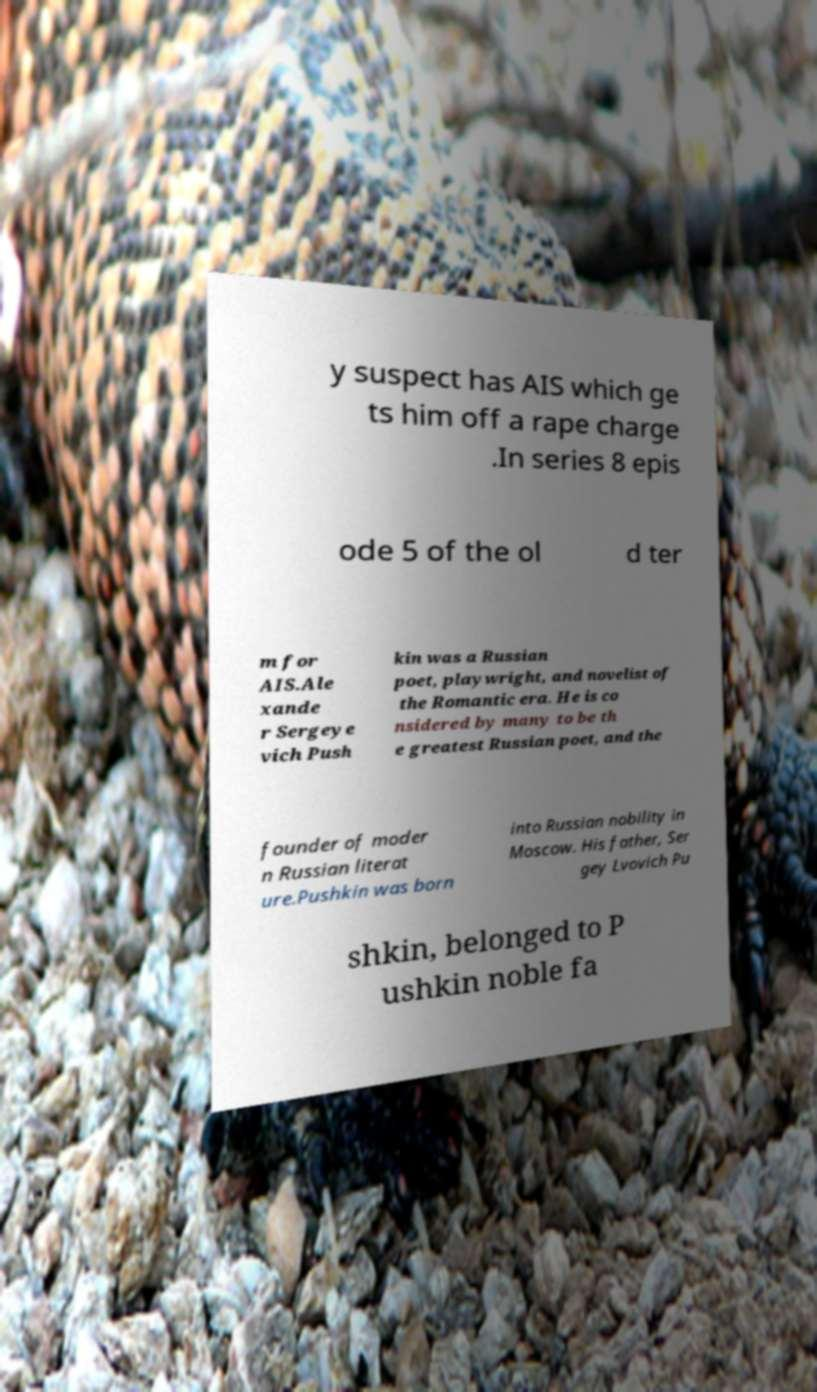Can you accurately transcribe the text from the provided image for me? y suspect has AIS which ge ts him off a rape charge .In series 8 epis ode 5 of the ol d ter m for AIS.Ale xande r Sergeye vich Push kin was a Russian poet, playwright, and novelist of the Romantic era. He is co nsidered by many to be th e greatest Russian poet, and the founder of moder n Russian literat ure.Pushkin was born into Russian nobility in Moscow. His father, Ser gey Lvovich Pu shkin, belonged to P ushkin noble fa 